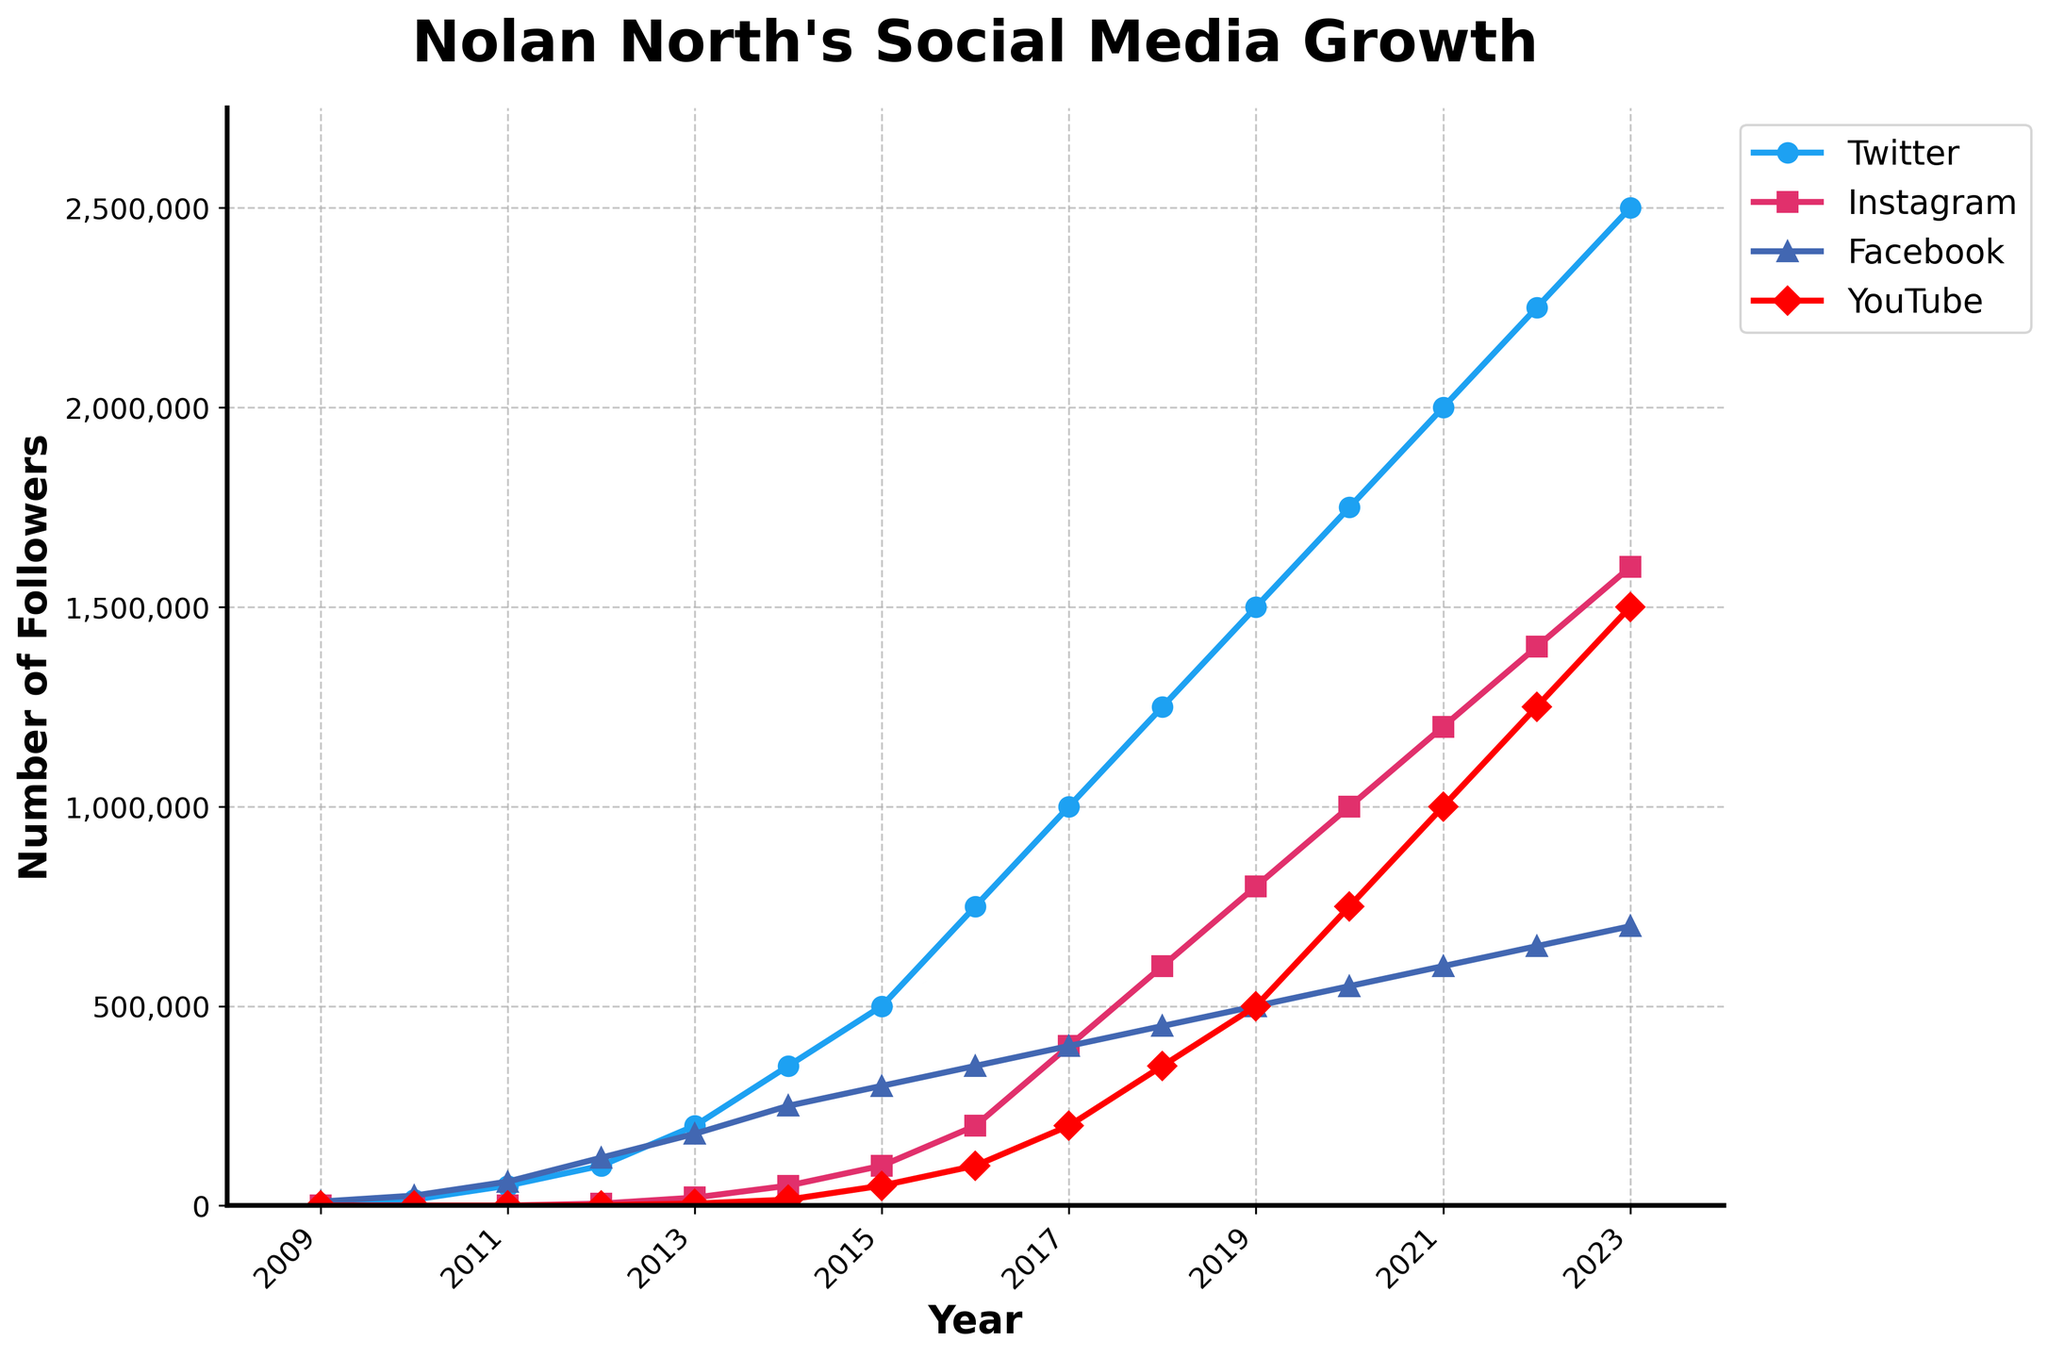What's the platform with the highest follower growth in 2023? In 2023, compare the endpoints of each line in the chart. The highest point corresponds to 2,500,000 followers on Twitter.
Answer: Twitter Which two years did Twitter followers double? Look at the pattern of the Twitter line. Followers doubled from 50,000 in 2011 to 100,000 in 2012, and again from 1,000,000 in 2017 to 2,000,000 in 2021.
Answer: 2011–2012 and 2017–2021 What was the combined follower count across all platforms in 2020? In 2020, sum the followers for all platforms: Twitter (1,750,000) + Instagram (1,000,000) + Facebook (550,000) + YouTube (750,000). The total is 4,050,000.
Answer: 4,050,000 Which platform saw the least growth overall from 2009 to 2023? Analyze the growth lines for all platforms. The Facebook line starts at 10,000 in 2009 and ends at 700,000 in 2023, which appears to be the smallest overall increase.
Answer: Facebook In which year did Instagram reach 1,000,000 followers? Observe the Instagram line which hits 1,000,000 followers in 2020.
Answer: 2020 How does the follower count for Facebook in 2018 compare to YouTube in the same year? In 2018, the Facebook line is at 450,000, and the YouTube line is at 350,000. Thus, Facebook had 100,000 more followers than YouTube in 2018.
Answer: Facebook had 100,000 more Which platform had a steeper growth from 2015 to 2016, Instagram or YouTube? Check the slope of the lines between 2015 and 2016. Instagram grows from 100,000 to 200,000 followers, increasing by 100,000 followers, whereas YouTube grows from 50,000 to 100,000, also increasing by 50,000 followers, showing Instagram had a steeper growth.
Answer: Instagram What was the total increase in Twitter followers from 2009 to 2023? Calculate the difference between Twitter followers in 2023 (2,500,000) and 2009 (5,000), resulting in an increase of 2,495,000.
Answer: 2,495,000 